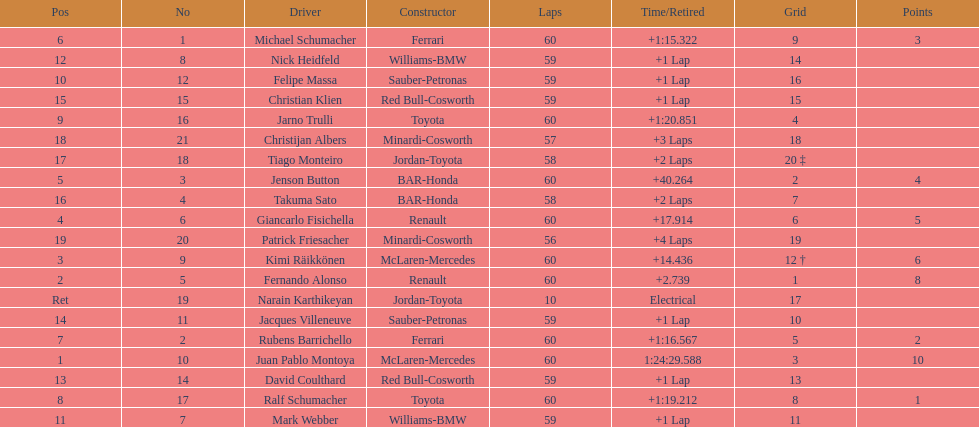How many drivers from germany? 3. 